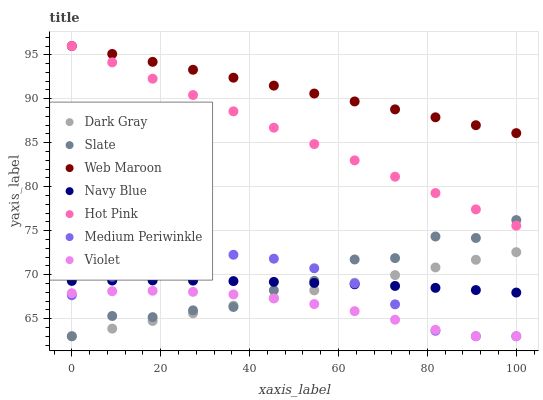Does Violet have the minimum area under the curve?
Answer yes or no. Yes. Does Web Maroon have the maximum area under the curve?
Answer yes or no. Yes. Does Navy Blue have the minimum area under the curve?
Answer yes or no. No. Does Navy Blue have the maximum area under the curve?
Answer yes or no. No. Is Hot Pink the smoothest?
Answer yes or no. Yes. Is Slate the roughest?
Answer yes or no. Yes. Is Navy Blue the smoothest?
Answer yes or no. No. Is Navy Blue the roughest?
Answer yes or no. No. Does Medium Periwinkle have the lowest value?
Answer yes or no. Yes. Does Navy Blue have the lowest value?
Answer yes or no. No. Does Web Maroon have the highest value?
Answer yes or no. Yes. Does Navy Blue have the highest value?
Answer yes or no. No. Is Violet less than Web Maroon?
Answer yes or no. Yes. Is Hot Pink greater than Navy Blue?
Answer yes or no. Yes. Does Navy Blue intersect Slate?
Answer yes or no. Yes. Is Navy Blue less than Slate?
Answer yes or no. No. Is Navy Blue greater than Slate?
Answer yes or no. No. Does Violet intersect Web Maroon?
Answer yes or no. No. 